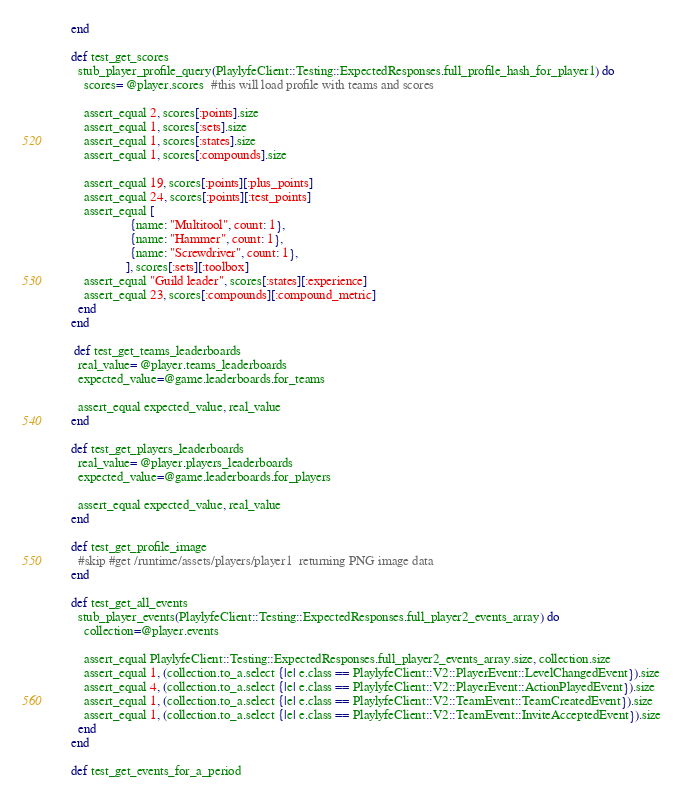<code> <loc_0><loc_0><loc_500><loc_500><_Ruby_>    end  
      
    def test_get_scores
      stub_player_profile_query(PlaylyfeClient::Testing::ExpectedResponses.full_profile_hash_for_player1) do
        scores= @player.scores  #this will load profile with teams and scores
       
        assert_equal 2, scores[:points].size
        assert_equal 1, scores[:sets].size
        assert_equal 1, scores[:states].size
        assert_equal 1, scores[:compounds].size

        assert_equal 19, scores[:points][:plus_points]
        assert_equal 24, scores[:points][:test_points]
        assert_equal [
                      {name: "Multitool", count: 1},
                      {name: "Hammer", count: 1}, 
                      {name: "Screwdriver", count: 1}, 
                     ], scores[:sets][:toolbox]
        assert_equal "Guild leader", scores[:states][:experience]
        assert_equal 23, scores[:compounds][:compound_metric]
      end  
    end  

     def test_get_teams_leaderboards
      real_value= @player.teams_leaderboards
      expected_value=@game.leaderboards.for_teams

      assert_equal expected_value, real_value
    end  

    def test_get_players_leaderboards
      real_value= @player.players_leaderboards
      expected_value=@game.leaderboards.for_players

      assert_equal expected_value, real_value
    end  

    def test_get_profile_image 
      #skip #get /runtime/assets/players/player1  returning PNG image data
    end  

    def test_get_all_events
      stub_player_events(PlaylyfeClient::Testing::ExpectedResponses.full_player2_events_array) do
        collection=@player.events
      
        assert_equal PlaylyfeClient::Testing::ExpectedResponses.full_player2_events_array.size, collection.size
        assert_equal 1, (collection.to_a.select {|e| e.class == PlaylyfeClient::V2::PlayerEvent::LevelChangedEvent}).size
        assert_equal 4, (collection.to_a.select {|e| e.class == PlaylyfeClient::V2::PlayerEvent::ActionPlayedEvent}).size
        assert_equal 1, (collection.to_a.select {|e| e.class == PlaylyfeClient::V2::TeamEvent::TeamCreatedEvent}).size
        assert_equal 1, (collection.to_a.select {|e| e.class == PlaylyfeClient::V2::TeamEvent::InviteAcceptedEvent}).size
      end  
    end    

    def test_get_events_for_a_period</code> 